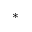<formula> <loc_0><loc_0><loc_500><loc_500>^ { * }</formula> 